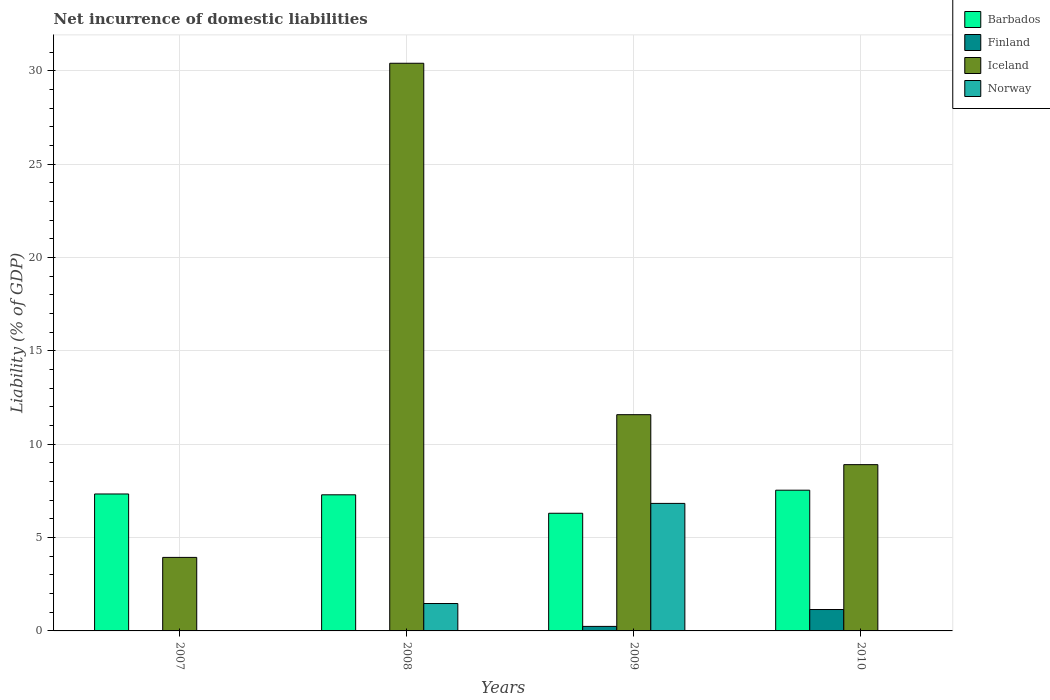How many groups of bars are there?
Your answer should be compact. 4. Are the number of bars on each tick of the X-axis equal?
Offer a terse response. No. What is the label of the 2nd group of bars from the left?
Provide a short and direct response. 2008. In how many cases, is the number of bars for a given year not equal to the number of legend labels?
Offer a very short reply. 3. What is the net incurrence of domestic liabilities in Norway in 2009?
Give a very brief answer. 6.83. Across all years, what is the maximum net incurrence of domestic liabilities in Norway?
Provide a short and direct response. 6.83. Across all years, what is the minimum net incurrence of domestic liabilities in Barbados?
Offer a very short reply. 6.3. What is the total net incurrence of domestic liabilities in Norway in the graph?
Make the answer very short. 8.3. What is the difference between the net incurrence of domestic liabilities in Barbados in 2009 and that in 2010?
Keep it short and to the point. -1.24. What is the difference between the net incurrence of domestic liabilities in Iceland in 2008 and the net incurrence of domestic liabilities in Norway in 2007?
Offer a very short reply. 30.41. What is the average net incurrence of domestic liabilities in Finland per year?
Keep it short and to the point. 0.35. In the year 2009, what is the difference between the net incurrence of domestic liabilities in Norway and net incurrence of domestic liabilities in Finland?
Offer a terse response. 6.59. In how many years, is the net incurrence of domestic liabilities in Iceland greater than 29 %?
Your response must be concise. 1. What is the ratio of the net incurrence of domestic liabilities in Barbados in 2008 to that in 2010?
Offer a terse response. 0.97. What is the difference between the highest and the second highest net incurrence of domestic liabilities in Iceland?
Your answer should be very brief. 18.83. What is the difference between the highest and the lowest net incurrence of domestic liabilities in Norway?
Your answer should be very brief. 6.83. Is the sum of the net incurrence of domestic liabilities in Barbados in 2007 and 2008 greater than the maximum net incurrence of domestic liabilities in Norway across all years?
Keep it short and to the point. Yes. Is it the case that in every year, the sum of the net incurrence of domestic liabilities in Iceland and net incurrence of domestic liabilities in Barbados is greater than the net incurrence of domestic liabilities in Norway?
Your answer should be compact. Yes. How many bars are there?
Keep it short and to the point. 12. Are all the bars in the graph horizontal?
Provide a succinct answer. No. How many years are there in the graph?
Keep it short and to the point. 4. Are the values on the major ticks of Y-axis written in scientific E-notation?
Ensure brevity in your answer.  No. Does the graph contain any zero values?
Ensure brevity in your answer.  Yes. Does the graph contain grids?
Your answer should be compact. Yes. Where does the legend appear in the graph?
Provide a short and direct response. Top right. How are the legend labels stacked?
Make the answer very short. Vertical. What is the title of the graph?
Offer a very short reply. Net incurrence of domestic liabilities. Does "Latin America(all income levels)" appear as one of the legend labels in the graph?
Provide a succinct answer. No. What is the label or title of the X-axis?
Ensure brevity in your answer.  Years. What is the label or title of the Y-axis?
Ensure brevity in your answer.  Liability (% of GDP). What is the Liability (% of GDP) in Barbados in 2007?
Give a very brief answer. 7.34. What is the Liability (% of GDP) in Finland in 2007?
Your answer should be very brief. 0. What is the Liability (% of GDP) of Iceland in 2007?
Keep it short and to the point. 3.94. What is the Liability (% of GDP) in Norway in 2007?
Your answer should be compact. 0. What is the Liability (% of GDP) in Barbados in 2008?
Provide a succinct answer. 7.29. What is the Liability (% of GDP) in Finland in 2008?
Make the answer very short. 0. What is the Liability (% of GDP) of Iceland in 2008?
Keep it short and to the point. 30.41. What is the Liability (% of GDP) of Norway in 2008?
Your response must be concise. 1.47. What is the Liability (% of GDP) of Barbados in 2009?
Make the answer very short. 6.3. What is the Liability (% of GDP) in Finland in 2009?
Offer a terse response. 0.24. What is the Liability (% of GDP) of Iceland in 2009?
Provide a short and direct response. 11.59. What is the Liability (% of GDP) in Norway in 2009?
Your answer should be compact. 6.83. What is the Liability (% of GDP) of Barbados in 2010?
Ensure brevity in your answer.  7.54. What is the Liability (% of GDP) of Finland in 2010?
Provide a short and direct response. 1.15. What is the Liability (% of GDP) of Iceland in 2010?
Provide a short and direct response. 8.91. Across all years, what is the maximum Liability (% of GDP) in Barbados?
Provide a short and direct response. 7.54. Across all years, what is the maximum Liability (% of GDP) in Finland?
Your response must be concise. 1.15. Across all years, what is the maximum Liability (% of GDP) in Iceland?
Give a very brief answer. 30.41. Across all years, what is the maximum Liability (% of GDP) in Norway?
Give a very brief answer. 6.83. Across all years, what is the minimum Liability (% of GDP) of Barbados?
Make the answer very short. 6.3. Across all years, what is the minimum Liability (% of GDP) in Finland?
Your answer should be very brief. 0. Across all years, what is the minimum Liability (% of GDP) of Iceland?
Provide a short and direct response. 3.94. Across all years, what is the minimum Liability (% of GDP) of Norway?
Your answer should be very brief. 0. What is the total Liability (% of GDP) in Barbados in the graph?
Provide a succinct answer. 28.48. What is the total Liability (% of GDP) of Finland in the graph?
Offer a very short reply. 1.39. What is the total Liability (% of GDP) in Iceland in the graph?
Provide a short and direct response. 54.85. What is the total Liability (% of GDP) in Norway in the graph?
Offer a very short reply. 8.3. What is the difference between the Liability (% of GDP) of Barbados in 2007 and that in 2008?
Provide a succinct answer. 0.04. What is the difference between the Liability (% of GDP) in Iceland in 2007 and that in 2008?
Ensure brevity in your answer.  -26.48. What is the difference between the Liability (% of GDP) of Barbados in 2007 and that in 2009?
Offer a very short reply. 1.03. What is the difference between the Liability (% of GDP) of Iceland in 2007 and that in 2009?
Give a very brief answer. -7.65. What is the difference between the Liability (% of GDP) in Barbados in 2007 and that in 2010?
Give a very brief answer. -0.2. What is the difference between the Liability (% of GDP) in Iceland in 2007 and that in 2010?
Offer a very short reply. -4.97. What is the difference between the Liability (% of GDP) in Iceland in 2008 and that in 2009?
Your answer should be compact. 18.83. What is the difference between the Liability (% of GDP) of Norway in 2008 and that in 2009?
Keep it short and to the point. -5.36. What is the difference between the Liability (% of GDP) of Barbados in 2008 and that in 2010?
Ensure brevity in your answer.  -0.25. What is the difference between the Liability (% of GDP) in Iceland in 2008 and that in 2010?
Your answer should be compact. 21.51. What is the difference between the Liability (% of GDP) of Barbados in 2009 and that in 2010?
Give a very brief answer. -1.24. What is the difference between the Liability (% of GDP) of Finland in 2009 and that in 2010?
Make the answer very short. -0.9. What is the difference between the Liability (% of GDP) in Iceland in 2009 and that in 2010?
Provide a short and direct response. 2.68. What is the difference between the Liability (% of GDP) in Barbados in 2007 and the Liability (% of GDP) in Iceland in 2008?
Offer a terse response. -23.08. What is the difference between the Liability (% of GDP) in Barbados in 2007 and the Liability (% of GDP) in Norway in 2008?
Give a very brief answer. 5.87. What is the difference between the Liability (% of GDP) of Iceland in 2007 and the Liability (% of GDP) of Norway in 2008?
Keep it short and to the point. 2.47. What is the difference between the Liability (% of GDP) of Barbados in 2007 and the Liability (% of GDP) of Finland in 2009?
Keep it short and to the point. 7.1. What is the difference between the Liability (% of GDP) of Barbados in 2007 and the Liability (% of GDP) of Iceland in 2009?
Give a very brief answer. -4.25. What is the difference between the Liability (% of GDP) in Barbados in 2007 and the Liability (% of GDP) in Norway in 2009?
Your response must be concise. 0.5. What is the difference between the Liability (% of GDP) of Iceland in 2007 and the Liability (% of GDP) of Norway in 2009?
Keep it short and to the point. -2.89. What is the difference between the Liability (% of GDP) of Barbados in 2007 and the Liability (% of GDP) of Finland in 2010?
Provide a succinct answer. 6.19. What is the difference between the Liability (% of GDP) of Barbados in 2007 and the Liability (% of GDP) of Iceland in 2010?
Keep it short and to the point. -1.57. What is the difference between the Liability (% of GDP) of Barbados in 2008 and the Liability (% of GDP) of Finland in 2009?
Provide a succinct answer. 7.05. What is the difference between the Liability (% of GDP) in Barbados in 2008 and the Liability (% of GDP) in Iceland in 2009?
Your answer should be compact. -4.29. What is the difference between the Liability (% of GDP) of Barbados in 2008 and the Liability (% of GDP) of Norway in 2009?
Keep it short and to the point. 0.46. What is the difference between the Liability (% of GDP) of Iceland in 2008 and the Liability (% of GDP) of Norway in 2009?
Keep it short and to the point. 23.58. What is the difference between the Liability (% of GDP) of Barbados in 2008 and the Liability (% of GDP) of Finland in 2010?
Offer a terse response. 6.15. What is the difference between the Liability (% of GDP) of Barbados in 2008 and the Liability (% of GDP) of Iceland in 2010?
Your response must be concise. -1.62. What is the difference between the Liability (% of GDP) in Barbados in 2009 and the Liability (% of GDP) in Finland in 2010?
Offer a very short reply. 5.16. What is the difference between the Liability (% of GDP) of Barbados in 2009 and the Liability (% of GDP) of Iceland in 2010?
Ensure brevity in your answer.  -2.6. What is the difference between the Liability (% of GDP) in Finland in 2009 and the Liability (% of GDP) in Iceland in 2010?
Offer a terse response. -8.67. What is the average Liability (% of GDP) in Barbados per year?
Your answer should be very brief. 7.12. What is the average Liability (% of GDP) in Finland per year?
Offer a very short reply. 0.35. What is the average Liability (% of GDP) of Iceland per year?
Your answer should be compact. 13.71. What is the average Liability (% of GDP) in Norway per year?
Make the answer very short. 2.08. In the year 2007, what is the difference between the Liability (% of GDP) of Barbados and Liability (% of GDP) of Iceland?
Give a very brief answer. 3.4. In the year 2008, what is the difference between the Liability (% of GDP) in Barbados and Liability (% of GDP) in Iceland?
Your answer should be very brief. -23.12. In the year 2008, what is the difference between the Liability (% of GDP) of Barbados and Liability (% of GDP) of Norway?
Offer a very short reply. 5.83. In the year 2008, what is the difference between the Liability (% of GDP) in Iceland and Liability (% of GDP) in Norway?
Offer a terse response. 28.95. In the year 2009, what is the difference between the Liability (% of GDP) in Barbados and Liability (% of GDP) in Finland?
Provide a succinct answer. 6.06. In the year 2009, what is the difference between the Liability (% of GDP) in Barbados and Liability (% of GDP) in Iceland?
Keep it short and to the point. -5.28. In the year 2009, what is the difference between the Liability (% of GDP) in Barbados and Liability (% of GDP) in Norway?
Provide a succinct answer. -0.53. In the year 2009, what is the difference between the Liability (% of GDP) in Finland and Liability (% of GDP) in Iceland?
Offer a very short reply. -11.34. In the year 2009, what is the difference between the Liability (% of GDP) in Finland and Liability (% of GDP) in Norway?
Give a very brief answer. -6.59. In the year 2009, what is the difference between the Liability (% of GDP) of Iceland and Liability (% of GDP) of Norway?
Provide a succinct answer. 4.75. In the year 2010, what is the difference between the Liability (% of GDP) in Barbados and Liability (% of GDP) in Finland?
Ensure brevity in your answer.  6.39. In the year 2010, what is the difference between the Liability (% of GDP) in Barbados and Liability (% of GDP) in Iceland?
Give a very brief answer. -1.37. In the year 2010, what is the difference between the Liability (% of GDP) of Finland and Liability (% of GDP) of Iceland?
Offer a terse response. -7.76. What is the ratio of the Liability (% of GDP) in Barbados in 2007 to that in 2008?
Offer a very short reply. 1.01. What is the ratio of the Liability (% of GDP) in Iceland in 2007 to that in 2008?
Provide a succinct answer. 0.13. What is the ratio of the Liability (% of GDP) in Barbados in 2007 to that in 2009?
Offer a very short reply. 1.16. What is the ratio of the Liability (% of GDP) in Iceland in 2007 to that in 2009?
Your answer should be very brief. 0.34. What is the ratio of the Liability (% of GDP) in Barbados in 2007 to that in 2010?
Give a very brief answer. 0.97. What is the ratio of the Liability (% of GDP) of Iceland in 2007 to that in 2010?
Keep it short and to the point. 0.44. What is the ratio of the Liability (% of GDP) in Barbados in 2008 to that in 2009?
Offer a very short reply. 1.16. What is the ratio of the Liability (% of GDP) in Iceland in 2008 to that in 2009?
Provide a succinct answer. 2.63. What is the ratio of the Liability (% of GDP) of Norway in 2008 to that in 2009?
Provide a short and direct response. 0.21. What is the ratio of the Liability (% of GDP) in Barbados in 2008 to that in 2010?
Provide a short and direct response. 0.97. What is the ratio of the Liability (% of GDP) of Iceland in 2008 to that in 2010?
Your answer should be compact. 3.41. What is the ratio of the Liability (% of GDP) of Barbados in 2009 to that in 2010?
Provide a short and direct response. 0.84. What is the ratio of the Liability (% of GDP) of Finland in 2009 to that in 2010?
Provide a succinct answer. 0.21. What is the ratio of the Liability (% of GDP) in Iceland in 2009 to that in 2010?
Your answer should be compact. 1.3. What is the difference between the highest and the second highest Liability (% of GDP) of Barbados?
Provide a short and direct response. 0.2. What is the difference between the highest and the second highest Liability (% of GDP) in Iceland?
Give a very brief answer. 18.83. What is the difference between the highest and the lowest Liability (% of GDP) in Barbados?
Your answer should be very brief. 1.24. What is the difference between the highest and the lowest Liability (% of GDP) in Finland?
Provide a succinct answer. 1.15. What is the difference between the highest and the lowest Liability (% of GDP) in Iceland?
Keep it short and to the point. 26.48. What is the difference between the highest and the lowest Liability (% of GDP) of Norway?
Provide a short and direct response. 6.83. 